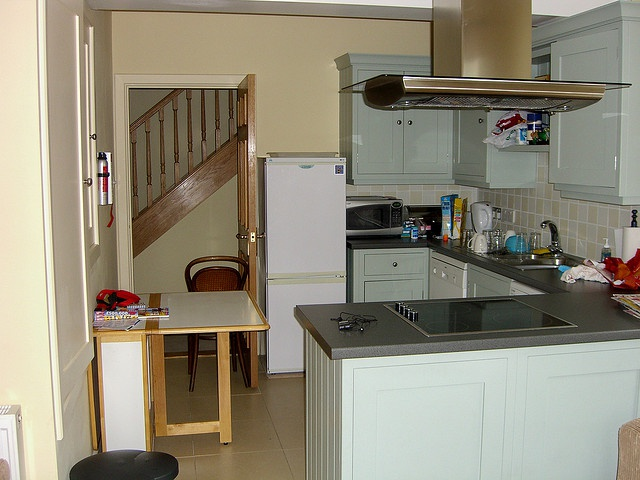Describe the objects in this image and their specific colors. I can see dining table in lightgray, tan, and maroon tones, refrigerator in lightgray, darkgray, and gray tones, oven in lightgray, black, gray, and darkgreen tones, chair in lightgray, black, maroon, and gray tones, and microwave in lightgray, black, gray, and darkgray tones in this image. 